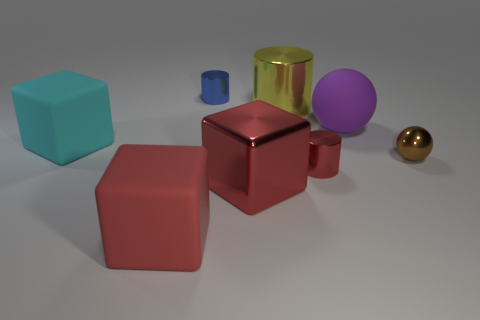Subtract all gray cylinders. How many red cubes are left? 2 Subtract all red cubes. How many cubes are left? 1 Add 1 big things. How many objects exist? 9 Subtract all cylinders. How many objects are left? 5 Subtract all cyan blocks. Subtract all big purple balls. How many objects are left? 6 Add 2 brown metal objects. How many brown metal objects are left? 3 Add 8 gray balls. How many gray balls exist? 8 Subtract 0 purple cylinders. How many objects are left? 8 